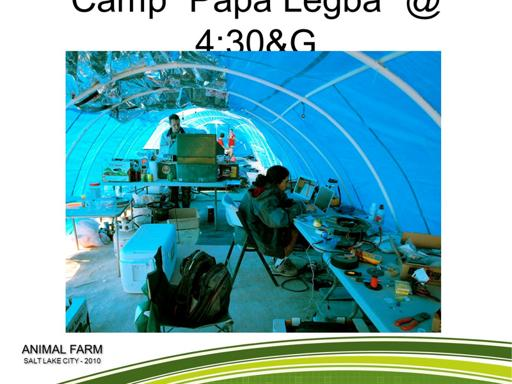What is the event mentioned in the image? The event shown in the image is called 'Animal Farm', hosted in Salt Lake City in the year 2010. This image captures a moment at the event which appears to be focused on technology or engineering works under a blue tent. 